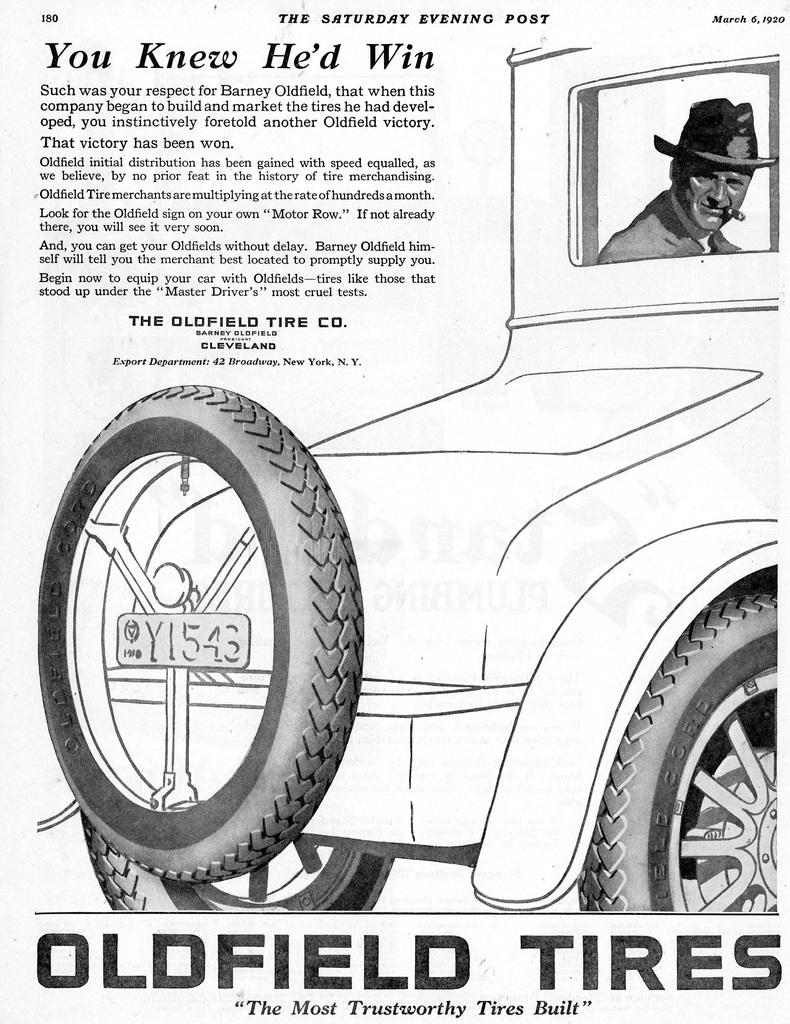What is the main subject of the image? There is a person in the image. What else can be seen in the image besides the person? There is a vehicle and text visible in the image. What type of image is this, based on its appearance? The image appears to be a newspaper cutting. How many eyes can be seen on the cloth in the image? There is no cloth or eyes present in the image. 